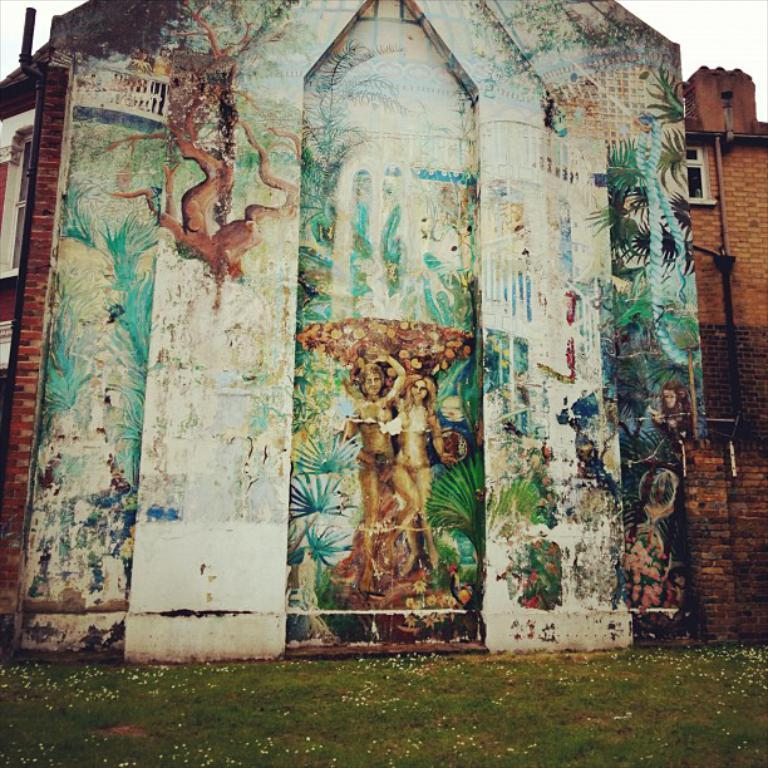What is depicted on the wall of the building in the image? There is a painting on the wall of a building. What type of vegetation is present in front of the wall? There is grass in front of the wall. Can you see a berry in the painting on the wall? There is no mention of a berry in the painting on the wall, so it cannot be confirmed or denied. Are the people in the painting smiling? There is no mention of people in the painting, so it cannot be confirmed or denied if they are smiling. 